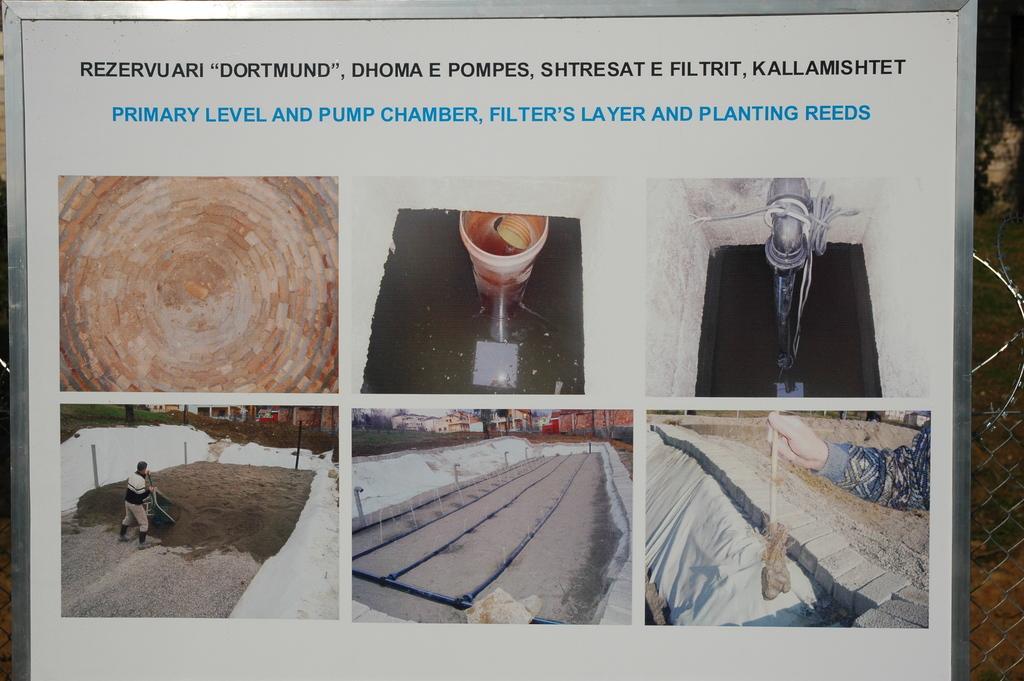Can you describe this image briefly? The picture consists of a board, in the board there is a sheet attached. In the sheet we can see text and colleges of images, in the images we can see water, bucket, person and some constructions. On the right it is looking like fencing. In the top right corner there are trees. 